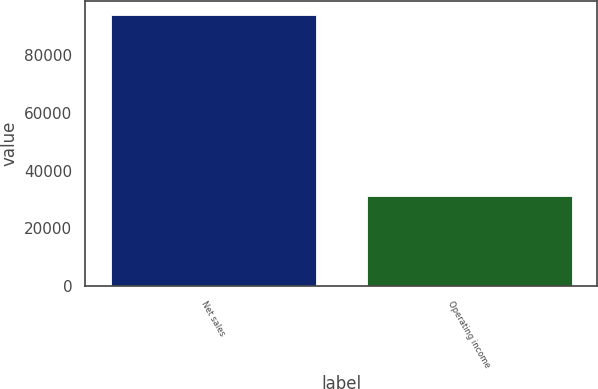<chart> <loc_0><loc_0><loc_500><loc_500><bar_chart><fcel>Net sales<fcel>Operating income<nl><fcel>93864<fcel>31186<nl></chart> 